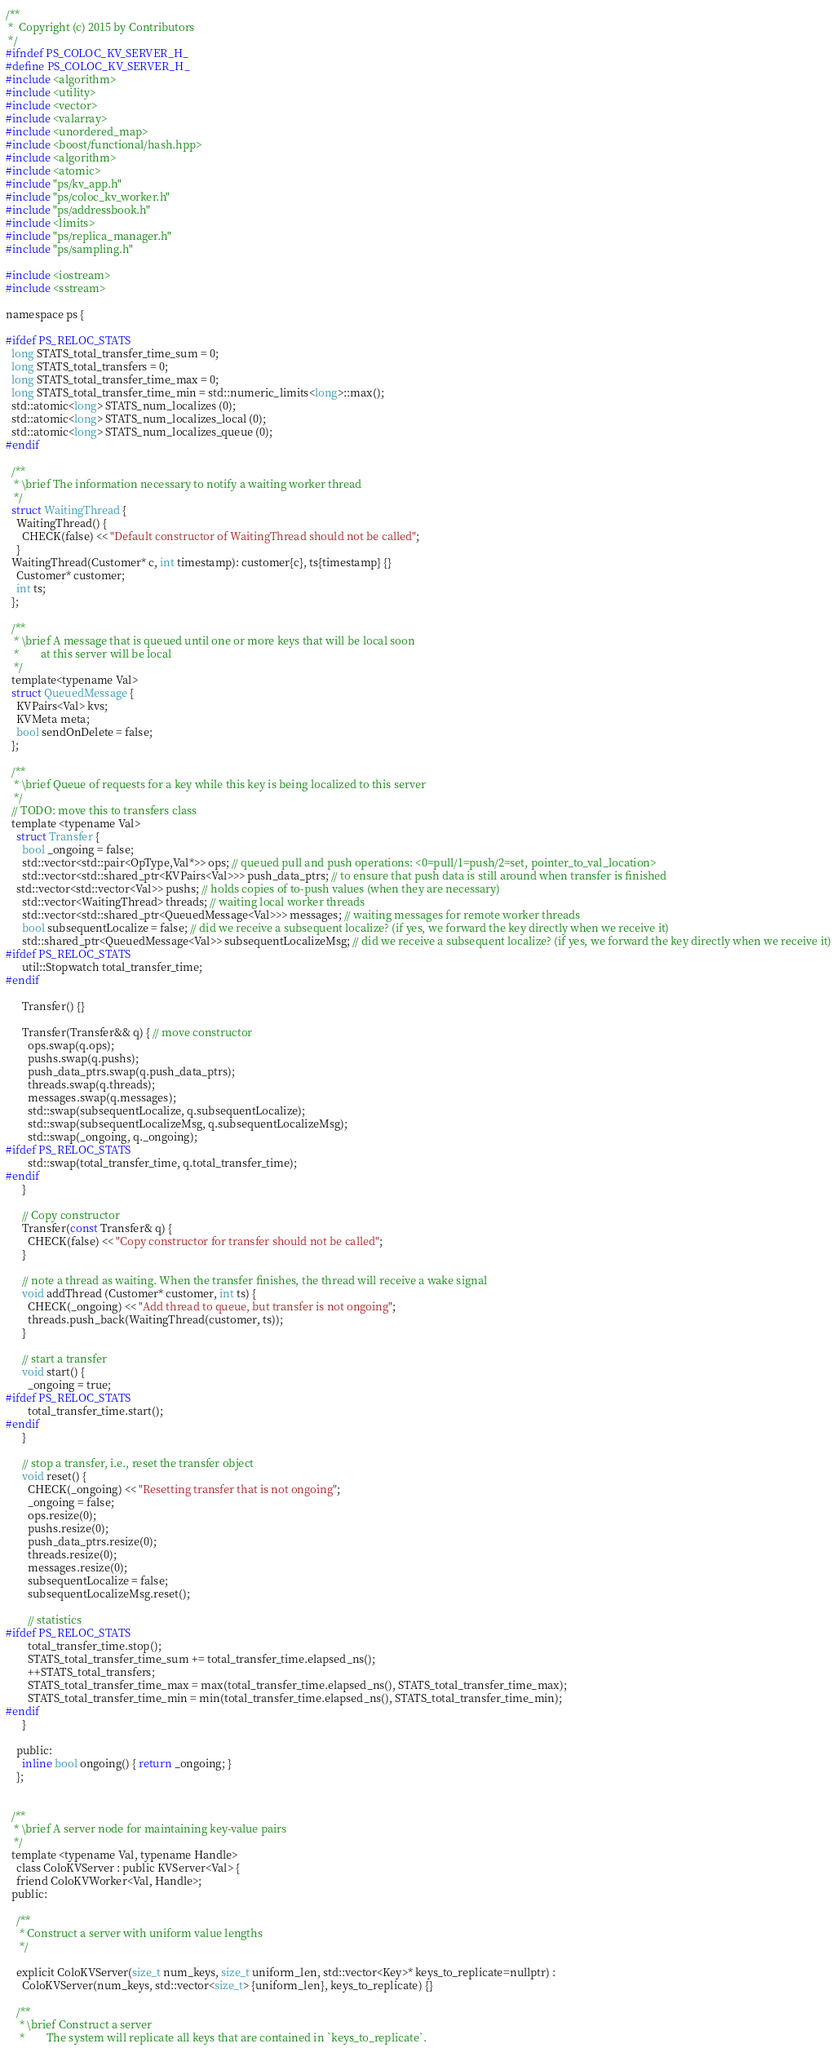Convert code to text. <code><loc_0><loc_0><loc_500><loc_500><_C_>/**
 *  Copyright (c) 2015 by Contributors
 */
#ifndef PS_COLOC_KV_SERVER_H_
#define PS_COLOC_KV_SERVER_H_
#include <algorithm>
#include <utility>
#include <vector>
#include <valarray>
#include <unordered_map>
#include <boost/functional/hash.hpp>
#include <algorithm>
#include <atomic>
#include "ps/kv_app.h"
#include "ps/coloc_kv_worker.h"
#include "ps/addressbook.h"
#include <limits>
#include "ps/replica_manager.h"
#include "ps/sampling.h"

#include <iostream>
#include <sstream>

namespace ps {

#ifdef PS_RELOC_STATS
  long STATS_total_transfer_time_sum = 0;
  long STATS_total_transfers = 0;
  long STATS_total_transfer_time_max = 0;
  long STATS_total_transfer_time_min = std::numeric_limits<long>::max();
  std::atomic<long> STATS_num_localizes (0);
  std::atomic<long> STATS_num_localizes_local (0);
  std::atomic<long> STATS_num_localizes_queue (0);
#endif

  /**
   * \brief The information necessary to notify a waiting worker thread
   */
  struct WaitingThread {
    WaitingThread() {
      CHECK(false) << "Default constructor of WaitingThread should not be called";
    }
  WaitingThread(Customer* c, int timestamp): customer{c}, ts{timestamp} {}
    Customer* customer;
    int ts;
  };

  /**
   * \brief A message that is queued until one or more keys that will be local soon
   *        at this server will be local
   */
  template<typename Val>
  struct QueuedMessage {
    KVPairs<Val> kvs;
    KVMeta meta;
    bool sendOnDelete = false;
  };

  /**
   * \brief Queue of requests for a key while this key is being localized to this server
   */
  // TODO: move this to transfers class
  template <typename Val>
    struct Transfer {
      bool _ongoing = false;
      std::vector<std::pair<OpType,Val*>> ops; // queued pull and push operations: <0=pull/1=push/2=set, pointer_to_val_location>
      std::vector<std::shared_ptr<KVPairs<Val>>> push_data_ptrs; // to ensure that push data is still around when transfer is finished
    std::vector<std::vector<Val>> pushs; // holds copies of to-push values (when they are necessary)
      std::vector<WaitingThread> threads; // waiting local worker threads
      std::vector<std::shared_ptr<QueuedMessage<Val>>> messages; // waiting messages for remote worker threads
      bool subsequentLocalize = false; // did we receive a subsequent localize? (if yes, we forward the key directly when we receive it)
      std::shared_ptr<QueuedMessage<Val>> subsequentLocalizeMsg; // did we receive a subsequent localize? (if yes, we forward the key directly when we receive it)
#ifdef PS_RELOC_STATS
      util::Stopwatch total_transfer_time;
#endif

      Transfer() {}

      Transfer(Transfer&& q) { // move constructor
        ops.swap(q.ops);
        pushs.swap(q.pushs);
        push_data_ptrs.swap(q.push_data_ptrs);
        threads.swap(q.threads);
        messages.swap(q.messages);
        std::swap(subsequentLocalize, q.subsequentLocalize);
        std::swap(subsequentLocalizeMsg, q.subsequentLocalizeMsg);
        std::swap(_ongoing, q._ongoing);
#ifdef PS_RELOC_STATS
        std::swap(total_transfer_time, q.total_transfer_time);
#endif
      }

      // Copy constructor
      Transfer(const Transfer& q) {
        CHECK(false) << "Copy constructor for transfer should not be called";
      }

      // note a thread as waiting. When the transfer finishes, the thread will receive a wake signal
      void addThread (Customer* customer, int ts) {
        CHECK(_ongoing) << "Add thread to queue, but transfer is not ongoing";
        threads.push_back(WaitingThread(customer, ts));
      }

      // start a transfer
      void start() {
        _ongoing = true;
#ifdef PS_RELOC_STATS
        total_transfer_time.start();
#endif
      }

      // stop a transfer, i.e., reset the transfer object
      void reset() {
        CHECK(_ongoing) << "Resetting transfer that is not ongoing";
        _ongoing = false;
        ops.resize(0);
        pushs.resize(0);
        push_data_ptrs.resize(0);
        threads.resize(0);
        messages.resize(0);
        subsequentLocalize = false;
        subsequentLocalizeMsg.reset();

        // statistics
#ifdef PS_RELOC_STATS
        total_transfer_time.stop();
        STATS_total_transfer_time_sum += total_transfer_time.elapsed_ns();
        ++STATS_total_transfers;
        STATS_total_transfer_time_max = max(total_transfer_time.elapsed_ns(), STATS_total_transfer_time_max);
        STATS_total_transfer_time_min = min(total_transfer_time.elapsed_ns(), STATS_total_transfer_time_min);
#endif
      }

    public:
      inline bool ongoing() { return _ongoing; }
    };


  /**
   * \brief A server node for maintaining key-value pairs
   */
  template <typename Val, typename Handle>
    class ColoKVServer : public KVServer<Val> {
    friend ColoKVWorker<Val, Handle>;
  public:

    /**
     * Construct a server with uniform value lengths
     */

    explicit ColoKVServer(size_t num_keys, size_t uniform_len, std::vector<Key>* keys_to_replicate=nullptr) :
      ColoKVServer(num_keys, std::vector<size_t> {uniform_len}, keys_to_replicate) {}

    /**
     * \brief Construct a server
     *        The system will replicate all keys that are contained in `keys_to_replicate`.</code> 